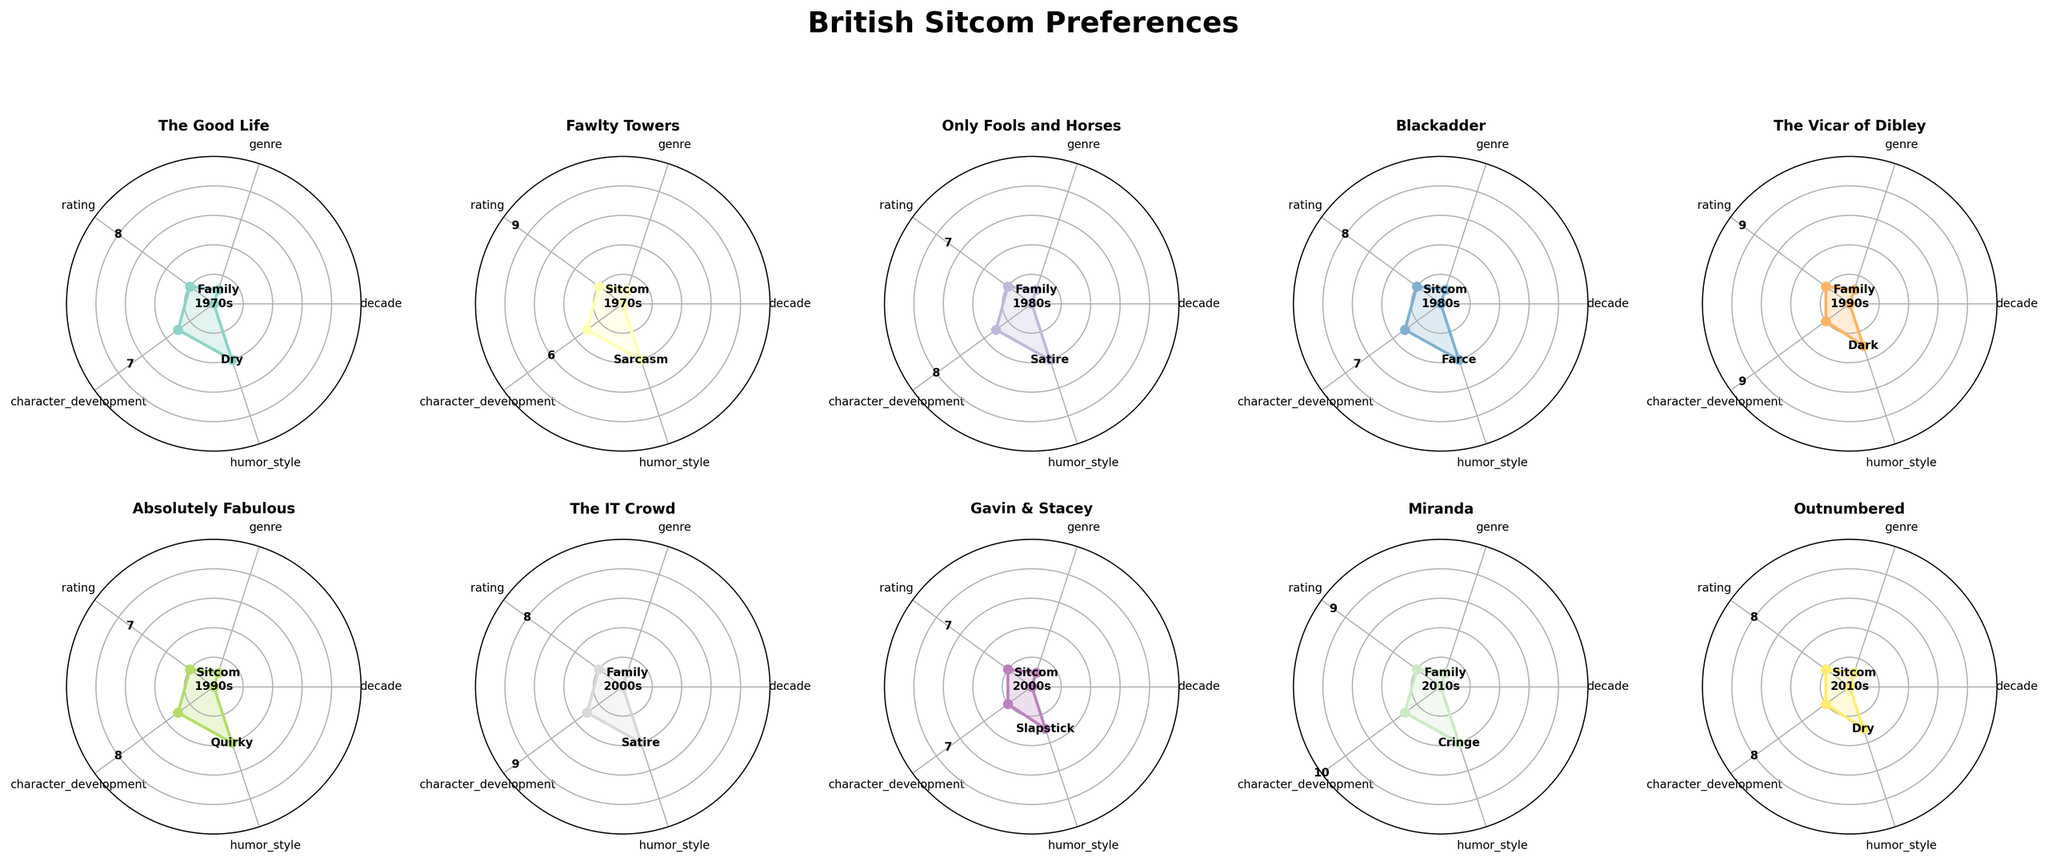Which show is represented in the 1970s with the highest rating? The shows in the 1970s are "The Good Life" and "Fawlty Towers". Fawlty Towers has a higher rating of 9 compared to The Good Life's rating of 8.
Answer: Fawlty Towers What is the average character development score for the shows from the 1990s? The shows from the 1990s are "The Vicar of Dibley" and "Absolutely Fabulous". The character development scores are 9 and 8 respectively. The average is (9 + 8) / 2 = 8.5.
Answer: 8.5 Which decade had the show with the higher character development score, the 1980s or the 2000s? The shows from the 1980s are "Only Fools and Horses" and "Blackadder" with character development scores of 8 and 7, respectively. The shows from the 2000s are "The IT Crowd" and "Gavin & Stacey" with character development scores of 9 and 7, respectively. The highest character development score in the 1980s is 8, and in the 2000s, it is 9. Thus, the 2000s had the higher score.
Answer: 2000s Compared to "Outnumbered," which shows have a lower humor style rating? "Outnumbered" has a humor style rating of 8. The shows with a lower humor style rating are "Fawlty Towers" (6), "Only Fools and Horses" (8 - not lower), "Blackadder" (7), "Absolutely Fabulous" (8 - not lower), "Gavin & Stacey" (7), and "The Good Life" (7).
Answer: Fawlty Towers, Blackadder, Gavin & Stacey, The Good Life 